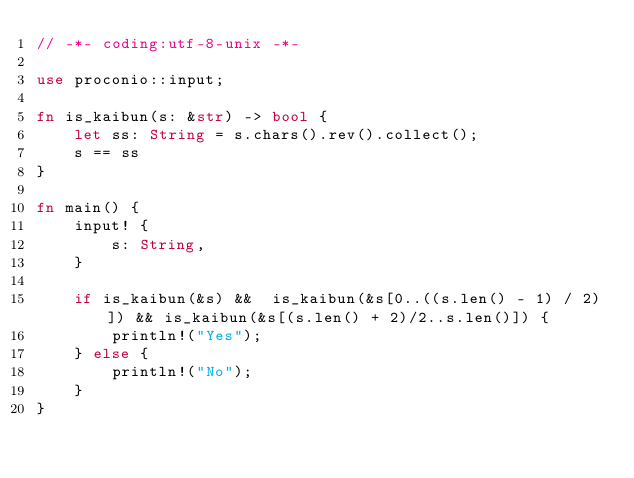<code> <loc_0><loc_0><loc_500><loc_500><_Rust_>// -*- coding:utf-8-unix -*-

use proconio::input;

fn is_kaibun(s: &str) -> bool {
    let ss: String = s.chars().rev().collect();
    s == ss
}

fn main() {
    input! {
        s: String,
    }

    if is_kaibun(&s) &&  is_kaibun(&s[0..((s.len() - 1) / 2)]) && is_kaibun(&s[(s.len() + 2)/2..s.len()]) {
        println!("Yes");
    } else {
        println!("No");
    }
}
</code> 